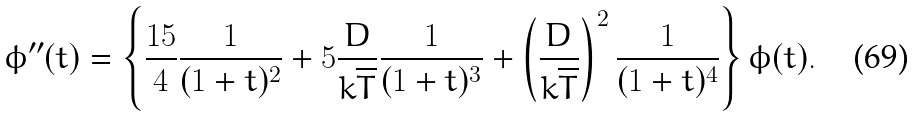Convert formula to latex. <formula><loc_0><loc_0><loc_500><loc_500>\phi ^ { \prime \prime } ( t ) = \left \{ \frac { 1 5 } { 4 } \frac { 1 } { ( 1 + t ) ^ { 2 } } + 5 \frac { D } { k \overline { T } } \frac { 1 } { ( 1 + t ) ^ { 3 } } + \left ( \frac { D } { k \overline { T } } \right ) ^ { 2 } \frac { 1 } { ( 1 + t ) ^ { 4 } } \right \} \phi ( t ) .</formula> 